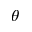<formula> <loc_0><loc_0><loc_500><loc_500>\theta</formula> 